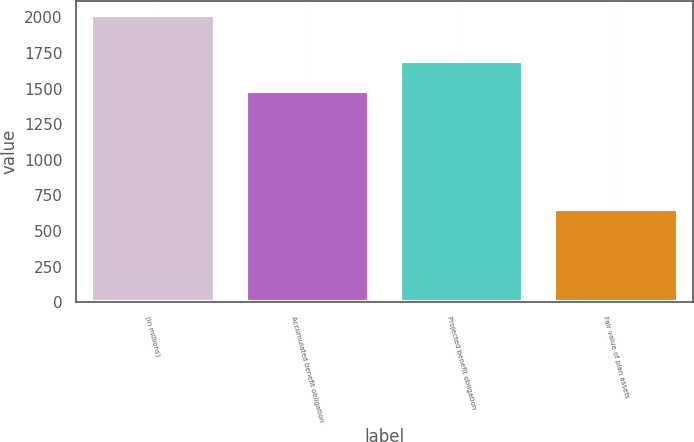Convert chart. <chart><loc_0><loc_0><loc_500><loc_500><bar_chart><fcel>(in millions)<fcel>Accumulated benefit obligation<fcel>Projected benefit obligation<fcel>Fair value of plan assets<nl><fcel>2016<fcel>1485<fcel>1697<fcel>653<nl></chart> 